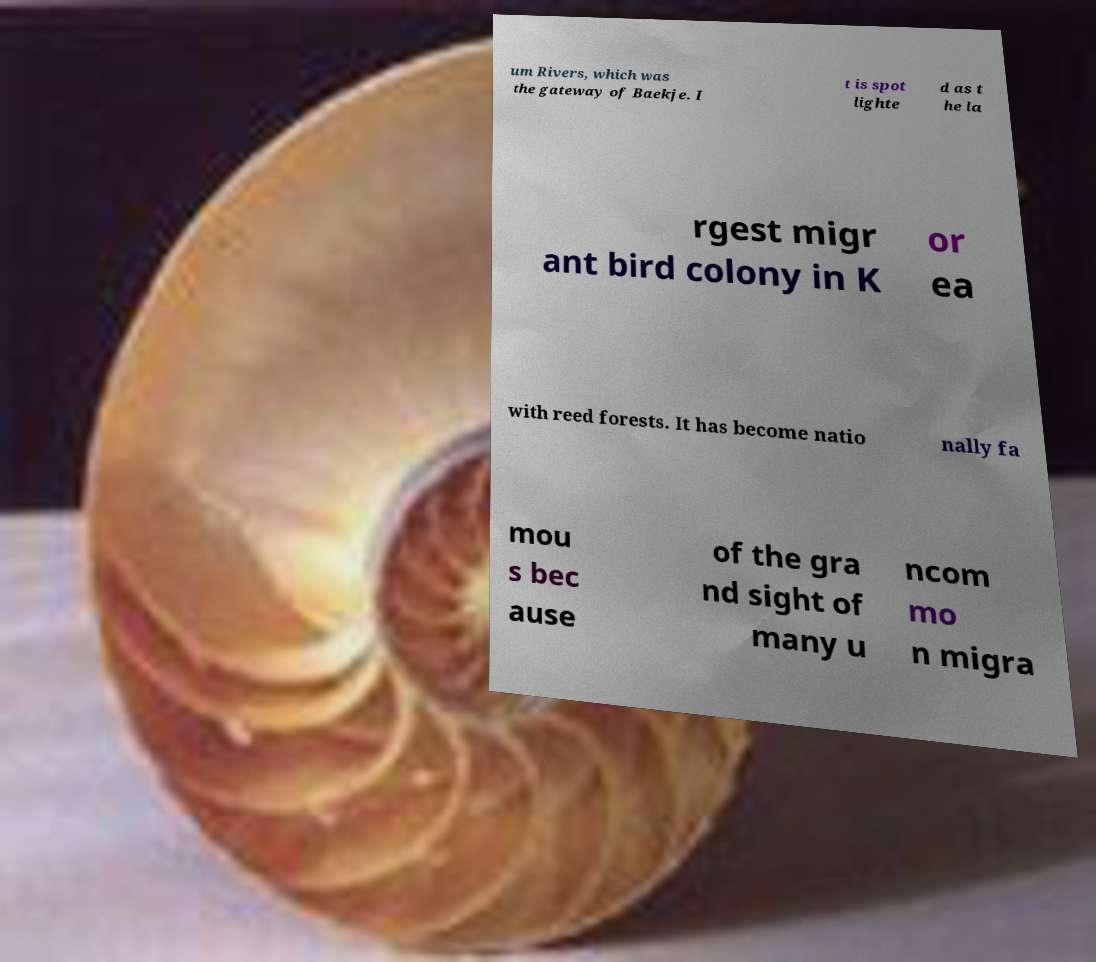What messages or text are displayed in this image? I need them in a readable, typed format. um Rivers, which was the gateway of Baekje. I t is spot lighte d as t he la rgest migr ant bird colony in K or ea with reed forests. It has become natio nally fa mou s bec ause of the gra nd sight of many u ncom mo n migra 